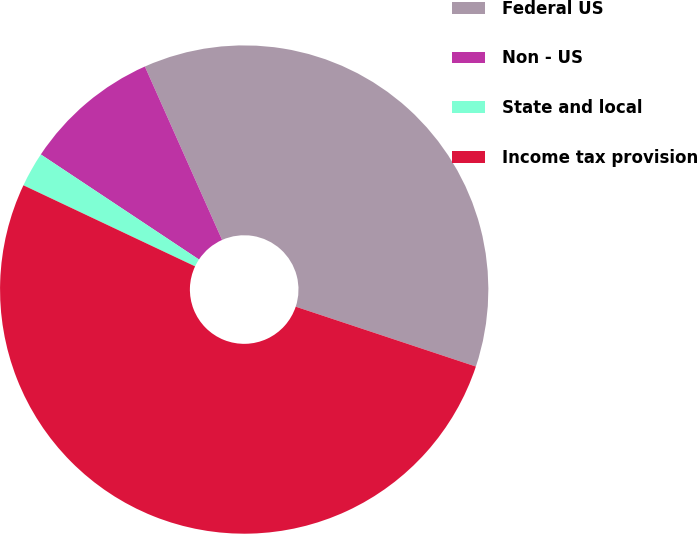Convert chart. <chart><loc_0><loc_0><loc_500><loc_500><pie_chart><fcel>Federal US<fcel>Non - US<fcel>State and local<fcel>Income tax provision<nl><fcel>36.77%<fcel>9.0%<fcel>2.31%<fcel>51.91%<nl></chart> 